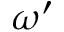<formula> <loc_0><loc_0><loc_500><loc_500>\omega ^ { \prime }</formula> 